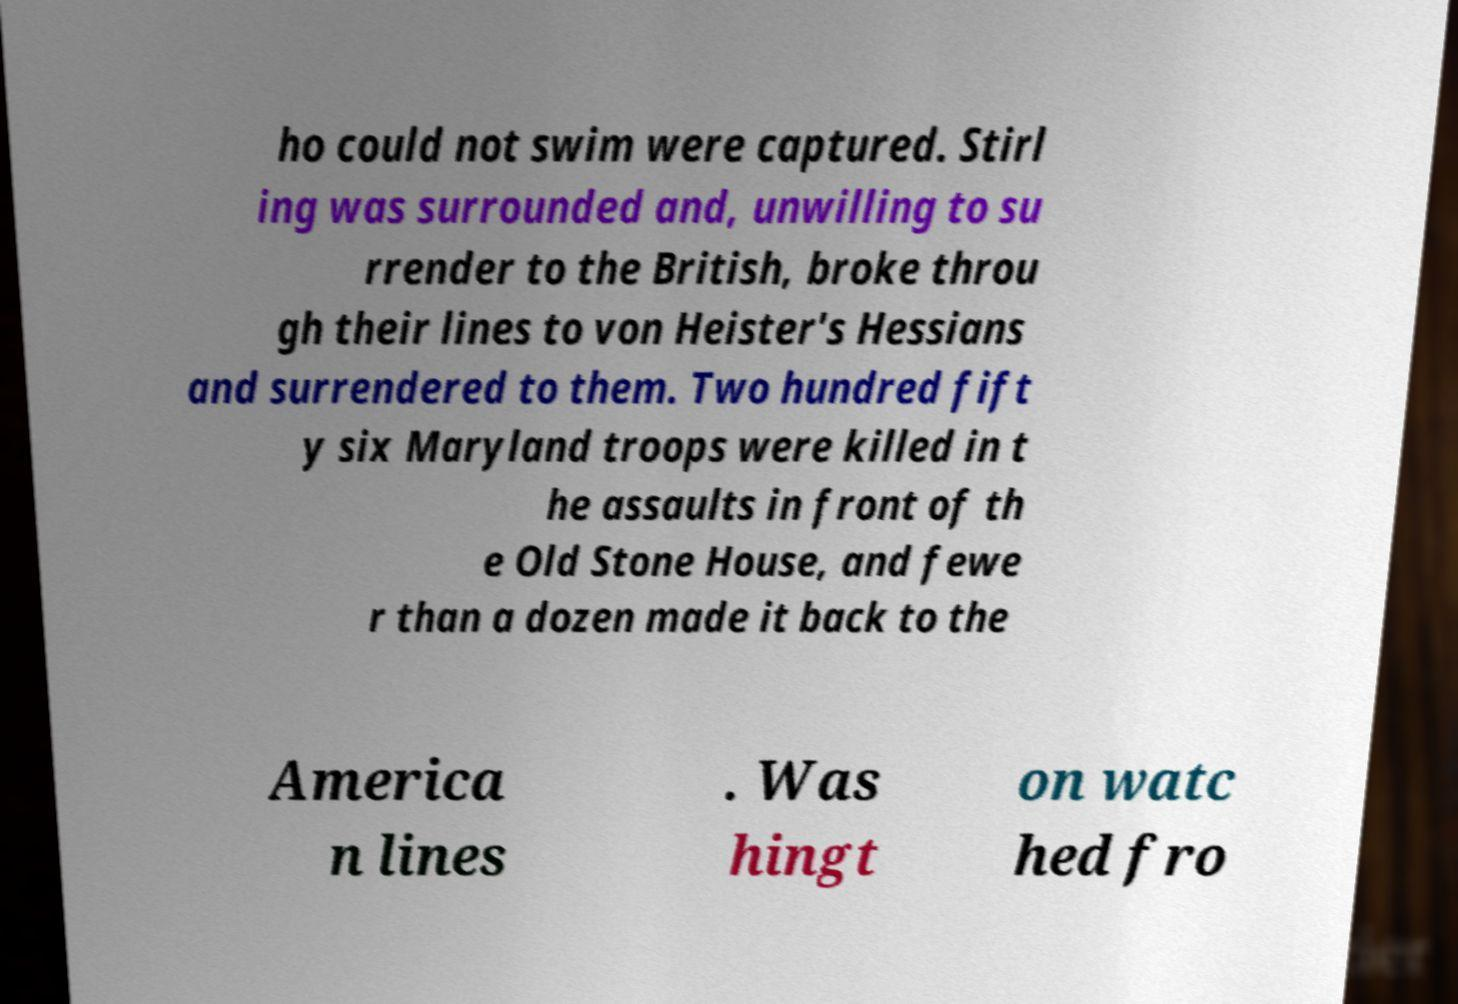Could you assist in decoding the text presented in this image and type it out clearly? ho could not swim were captured. Stirl ing was surrounded and, unwilling to su rrender to the British, broke throu gh their lines to von Heister's Hessians and surrendered to them. Two hundred fift y six Maryland troops were killed in t he assaults in front of th e Old Stone House, and fewe r than a dozen made it back to the America n lines . Was hingt on watc hed fro 